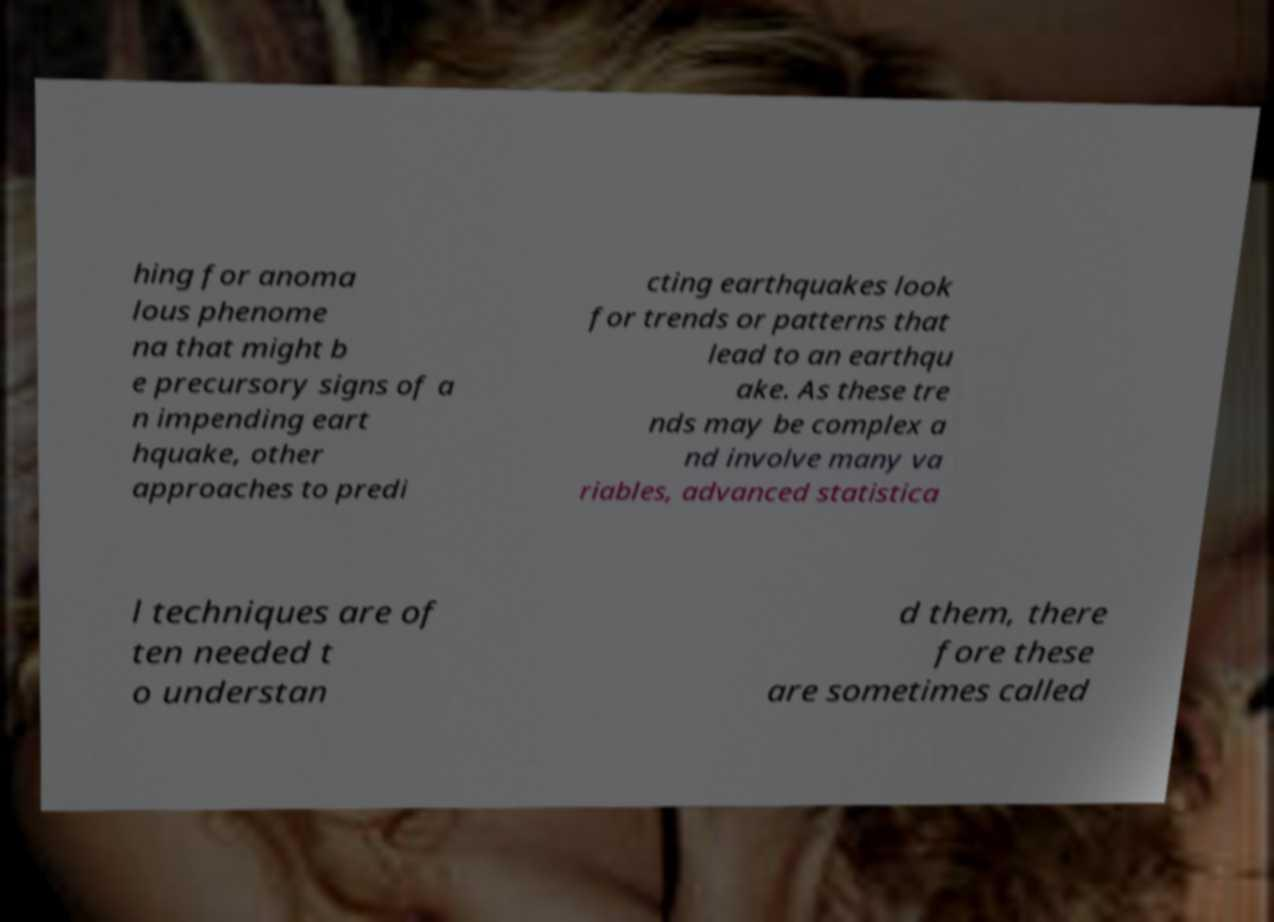I need the written content from this picture converted into text. Can you do that? hing for anoma lous phenome na that might b e precursory signs of a n impending eart hquake, other approaches to predi cting earthquakes look for trends or patterns that lead to an earthqu ake. As these tre nds may be complex a nd involve many va riables, advanced statistica l techniques are of ten needed t o understan d them, there fore these are sometimes called 